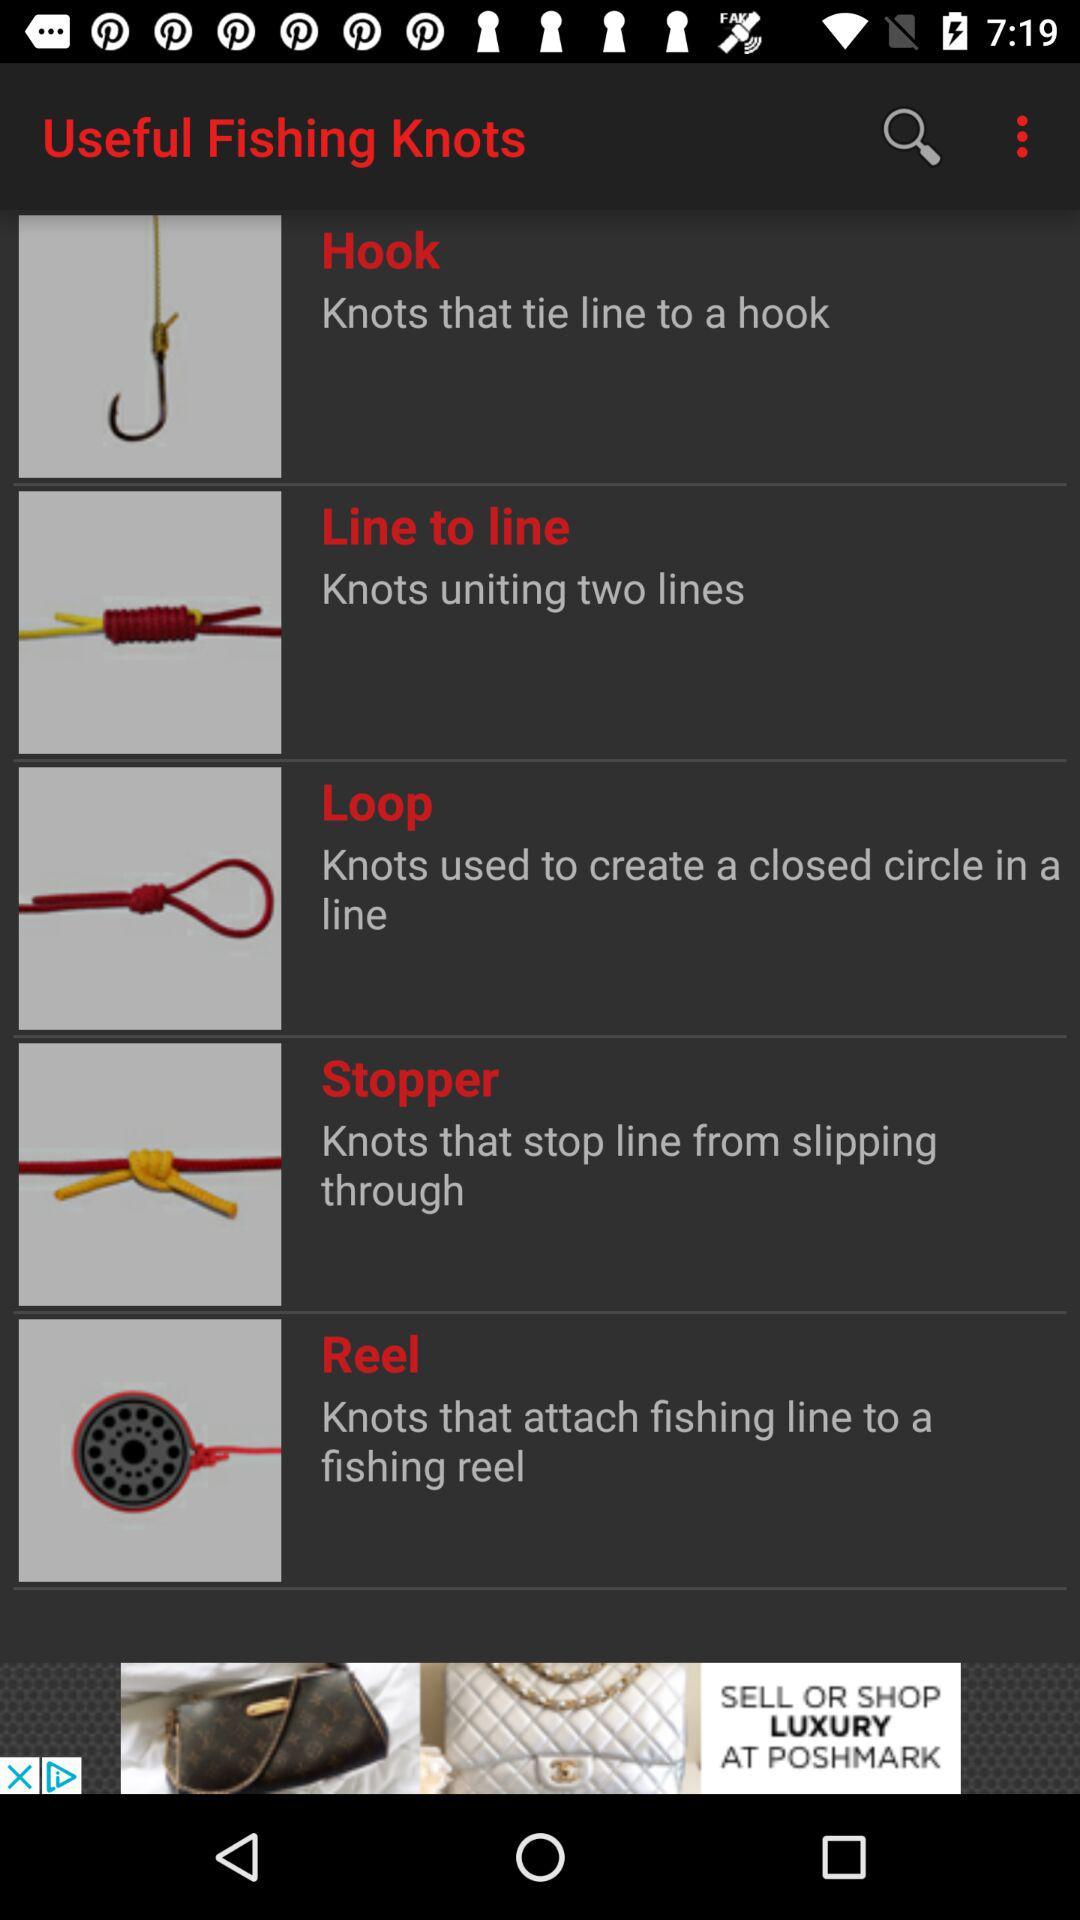What are the different types of fishing knots? The different types of fishing knots are "Hook", "Line to line", "Loop", "Stopper" and "Reel". 